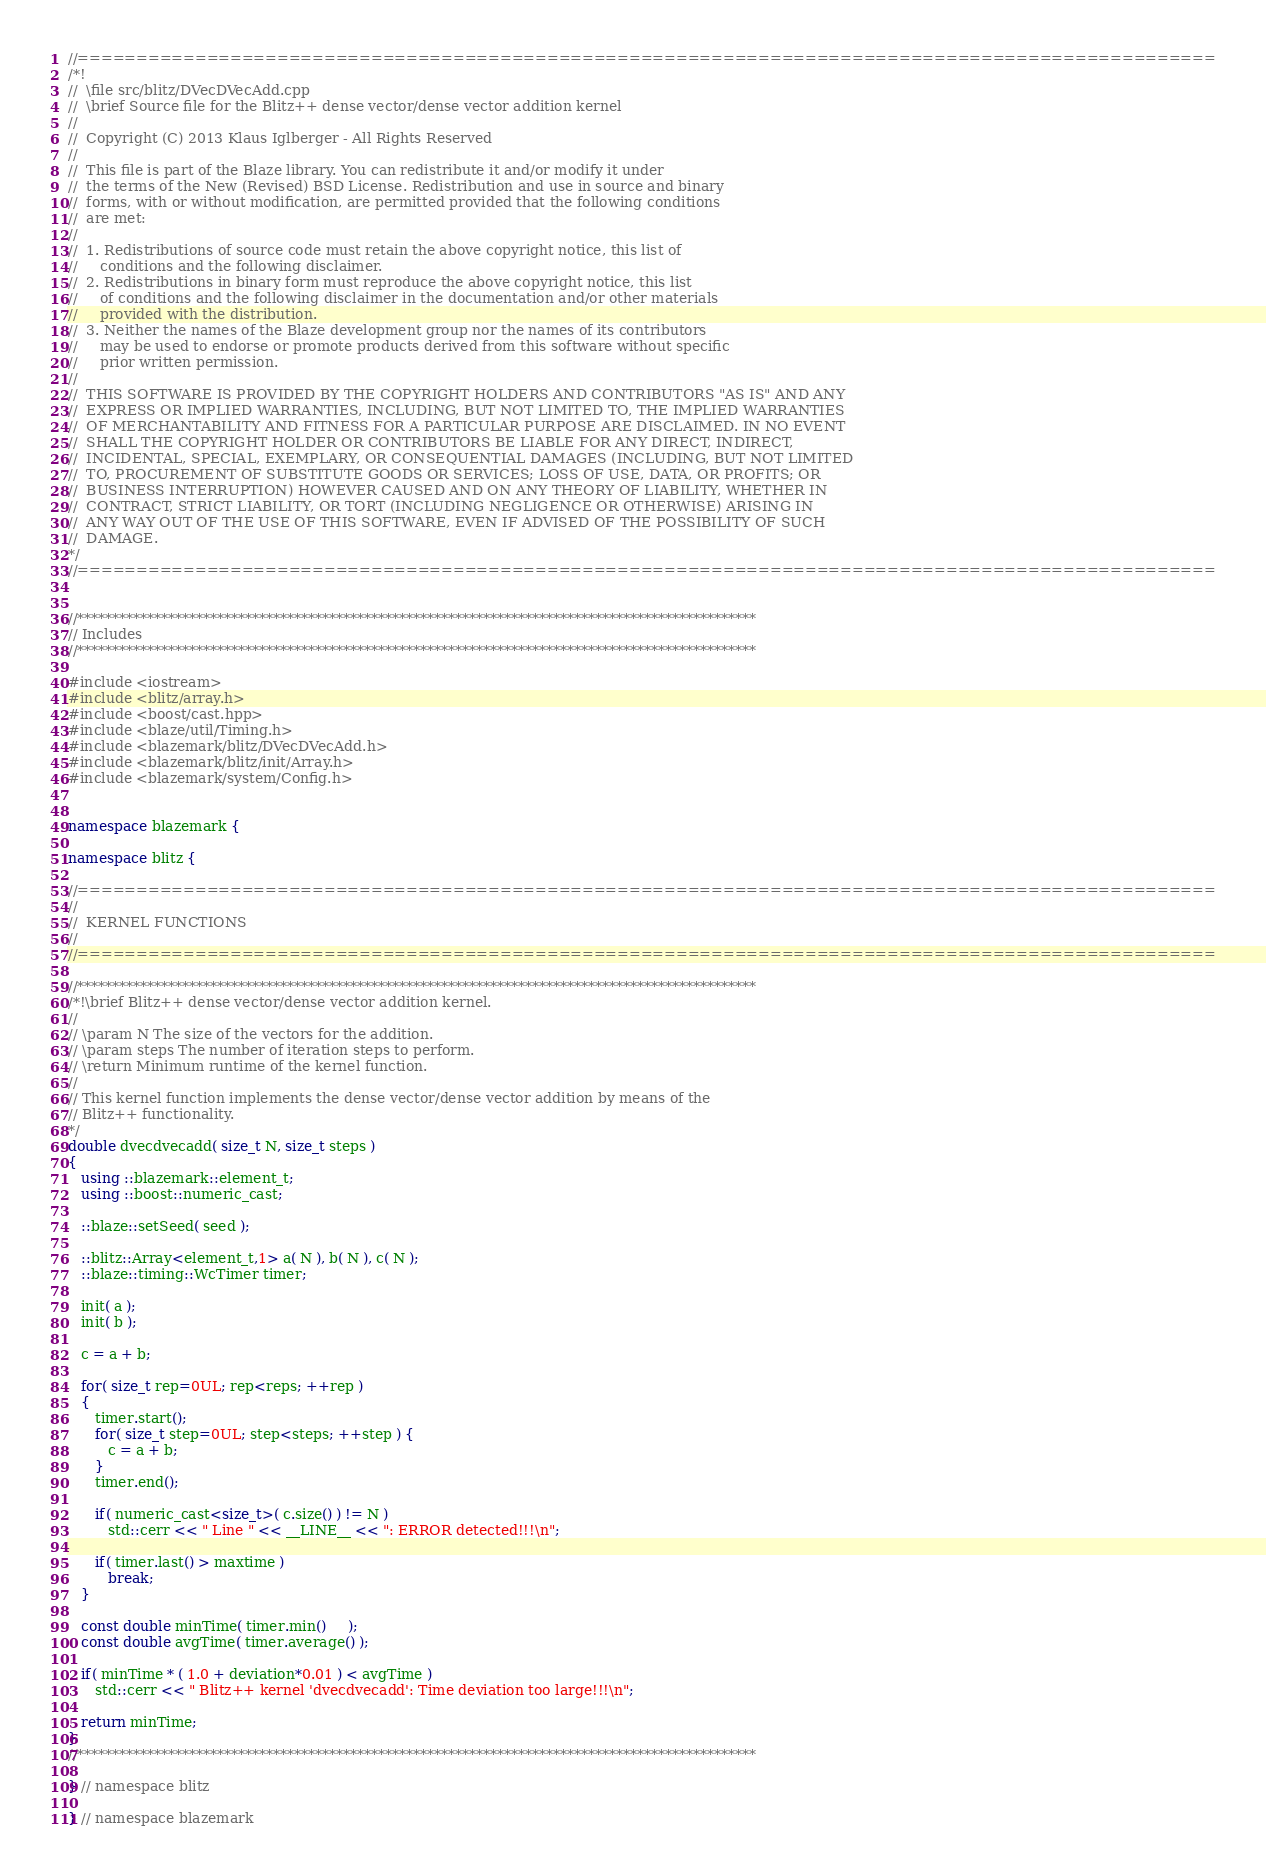Convert code to text. <code><loc_0><loc_0><loc_500><loc_500><_C++_>//=================================================================================================
/*!
//  \file src/blitz/DVecDVecAdd.cpp
//  \brief Source file for the Blitz++ dense vector/dense vector addition kernel
//
//  Copyright (C) 2013 Klaus Iglberger - All Rights Reserved
//
//  This file is part of the Blaze library. You can redistribute it and/or modify it under
//  the terms of the New (Revised) BSD License. Redistribution and use in source and binary
//  forms, with or without modification, are permitted provided that the following conditions
//  are met:
//
//  1. Redistributions of source code must retain the above copyright notice, this list of
//     conditions and the following disclaimer.
//  2. Redistributions in binary form must reproduce the above copyright notice, this list
//     of conditions and the following disclaimer in the documentation and/or other materials
//     provided with the distribution.
//  3. Neither the names of the Blaze development group nor the names of its contributors
//     may be used to endorse or promote products derived from this software without specific
//     prior written permission.
//
//  THIS SOFTWARE IS PROVIDED BY THE COPYRIGHT HOLDERS AND CONTRIBUTORS "AS IS" AND ANY
//  EXPRESS OR IMPLIED WARRANTIES, INCLUDING, BUT NOT LIMITED TO, THE IMPLIED WARRANTIES
//  OF MERCHANTABILITY AND FITNESS FOR A PARTICULAR PURPOSE ARE DISCLAIMED. IN NO EVENT
//  SHALL THE COPYRIGHT HOLDER OR CONTRIBUTORS BE LIABLE FOR ANY DIRECT, INDIRECT,
//  INCIDENTAL, SPECIAL, EXEMPLARY, OR CONSEQUENTIAL DAMAGES (INCLUDING, BUT NOT LIMITED
//  TO, PROCUREMENT OF SUBSTITUTE GOODS OR SERVICES; LOSS OF USE, DATA, OR PROFITS; OR
//  BUSINESS INTERRUPTION) HOWEVER CAUSED AND ON ANY THEORY OF LIABILITY, WHETHER IN
//  CONTRACT, STRICT LIABILITY, OR TORT (INCLUDING NEGLIGENCE OR OTHERWISE) ARISING IN
//  ANY WAY OUT OF THE USE OF THIS SOFTWARE, EVEN IF ADVISED OF THE POSSIBILITY OF SUCH
//  DAMAGE.
*/
//=================================================================================================


//*************************************************************************************************
// Includes
//*************************************************************************************************

#include <iostream>
#include <blitz/array.h>
#include <boost/cast.hpp>
#include <blaze/util/Timing.h>
#include <blazemark/blitz/DVecDVecAdd.h>
#include <blazemark/blitz/init/Array.h>
#include <blazemark/system/Config.h>


namespace blazemark {

namespace blitz {

//=================================================================================================
//
//  KERNEL FUNCTIONS
//
//=================================================================================================

//*************************************************************************************************
/*!\brief Blitz++ dense vector/dense vector addition kernel.
//
// \param N The size of the vectors for the addition.
// \param steps The number of iteration steps to perform.
// \return Minimum runtime of the kernel function.
//
// This kernel function implements the dense vector/dense vector addition by means of the
// Blitz++ functionality.
*/
double dvecdvecadd( size_t N, size_t steps )
{
   using ::blazemark::element_t;
   using ::boost::numeric_cast;

   ::blaze::setSeed( seed );

   ::blitz::Array<element_t,1> a( N ), b( N ), c( N );
   ::blaze::timing::WcTimer timer;

   init( a );
   init( b );

   c = a + b;

   for( size_t rep=0UL; rep<reps; ++rep )
   {
      timer.start();
      for( size_t step=0UL; step<steps; ++step ) {
         c = a + b;
      }
      timer.end();

      if( numeric_cast<size_t>( c.size() ) != N )
         std::cerr << " Line " << __LINE__ << ": ERROR detected!!!\n";

      if( timer.last() > maxtime )
         break;
   }

   const double minTime( timer.min()     );
   const double avgTime( timer.average() );

   if( minTime * ( 1.0 + deviation*0.01 ) < avgTime )
      std::cerr << " Blitz++ kernel 'dvecdvecadd': Time deviation too large!!!\n";

   return minTime;
}
//*************************************************************************************************

} // namespace blitz

} // namespace blazemark
</code> 